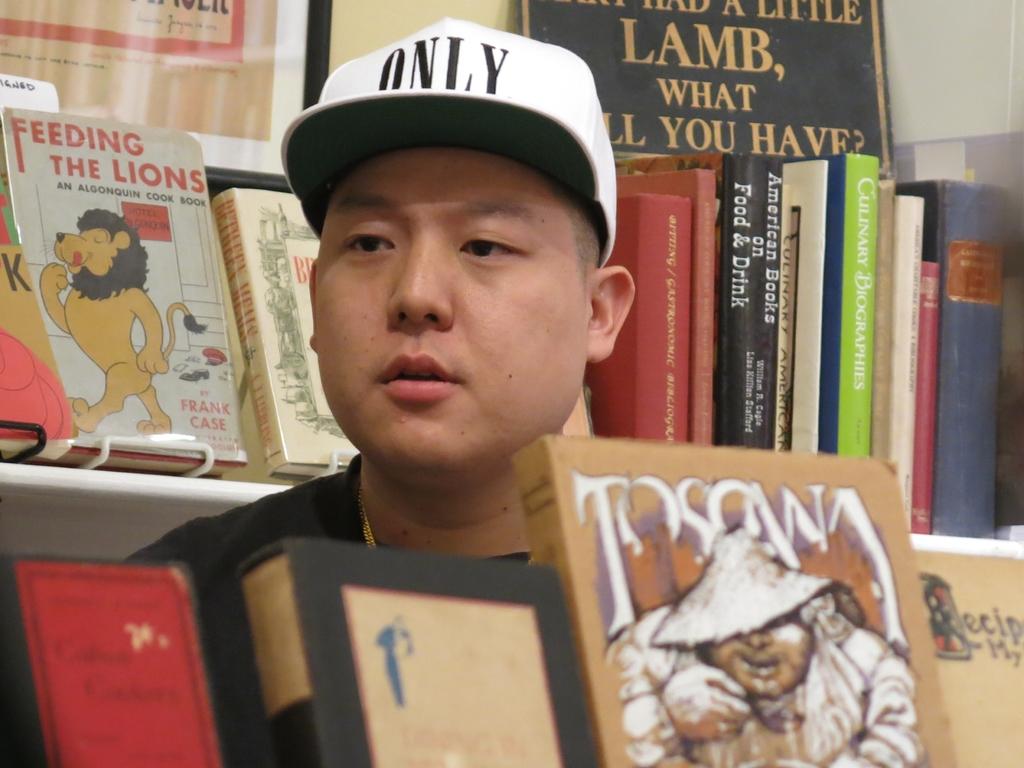Who is the author of the book with the lion on the cover?
Keep it short and to the point. Frank case. What is written on his hat?
Give a very brief answer. Only. 